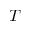<formula> <loc_0><loc_0><loc_500><loc_500>T</formula> 